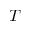<formula> <loc_0><loc_0><loc_500><loc_500>T</formula> 